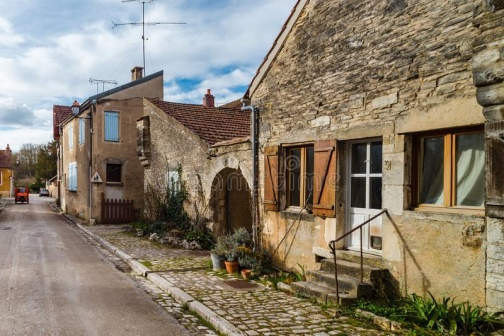What's happening in the scene? The image depicts a tranquil afternoon in a small, rustic village. A cobblestone street meanders through the heart of the village, bordered by charming stone houses with distinctively colorful roofs and doors. Notable features include the house on the far right, which boasts a quaint garden filled with potted plants enclosed by a traditional wooden gate. The center house presents a welcoming facade with a white door and shutters painted a soft green, while the house on the left adds a dash of vibrancy with its blue door. Overhead, electrical lines crisscross against a clear sky, connecting these timeless homes, while a lone street lamp stands by, poised to illuminate the path at twilight. This scene captures the essence of village life, offering a glimpse into a world where time slows and beauty resides in simplicity. 